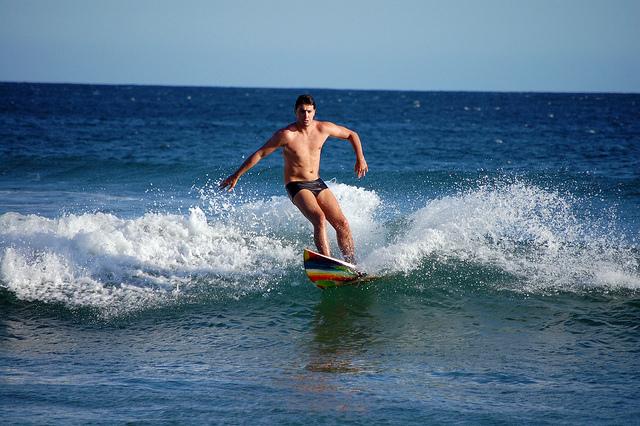What color is the surfboard?
Give a very brief answer. Rainbow. Is this surfer skilled?
Quick response, please. Yes. What color is his board?
Concise answer only. Rainbow. Are they wearing vests?
Give a very brief answer. No. What color are the shorts?
Give a very brief answer. Black. Is the man scared?
Be succinct. No. Is it a hot day?
Quick response, please. Yes. 